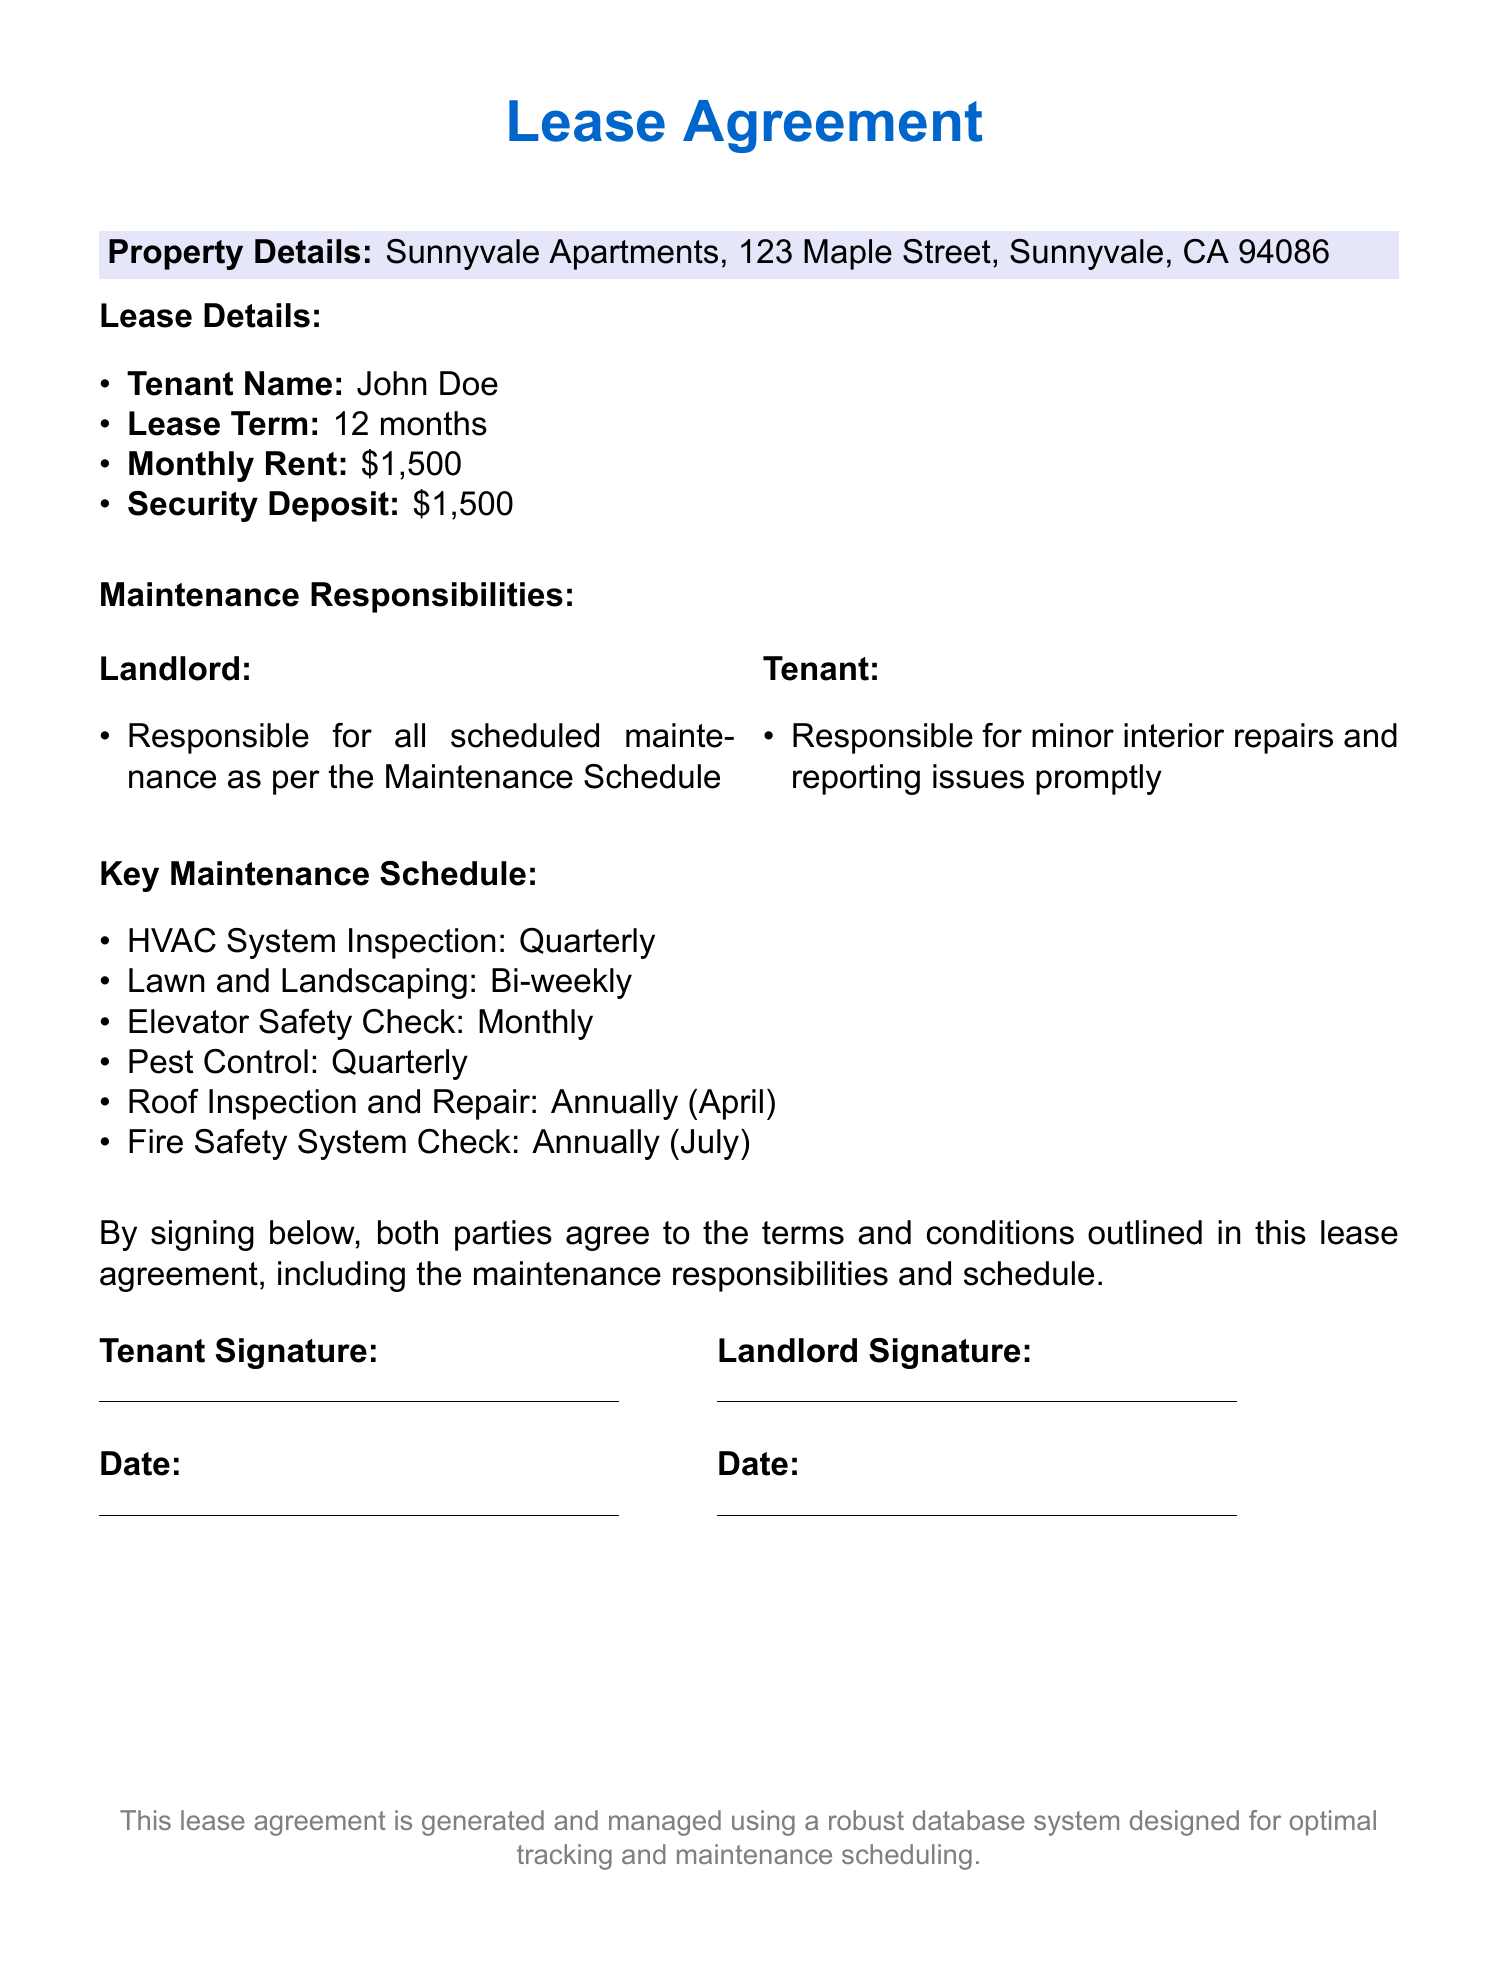What is the property address? The property address is specified in the document under Property Details.
Answer: 123 Maple Street, Sunnyvale, CA 94086 Who is the tenant named in the lease? The tenant's name is mentioned in the Lease Details section of the document.
Answer: John Doe How much is the monthly rent? The monthly rent is listed in the Lease Details section.
Answer: $1,500 What is the frequency of the HVAC system inspection? The Maintenance Schedule outlines the frequency for HVAC system inspections.
Answer: Quarterly Who is responsible for lawn and landscaping maintenance? The responsibilities for lawn and landscaping are detailed in the Maintenance Responsibilities section.
Answer: Landlord When is the roof inspection scheduled? The Maintenance Schedule specifies when the roof inspection will take place.
Answer: Annually (April) What date is the fire safety system check scheduled for? The Maintenance Schedule states when the fire safety system check occurs.
Answer: Annually (July) What is the security deposit amount? The security deposit amount is disclosed in the Lease Details section.
Answer: $1,500 